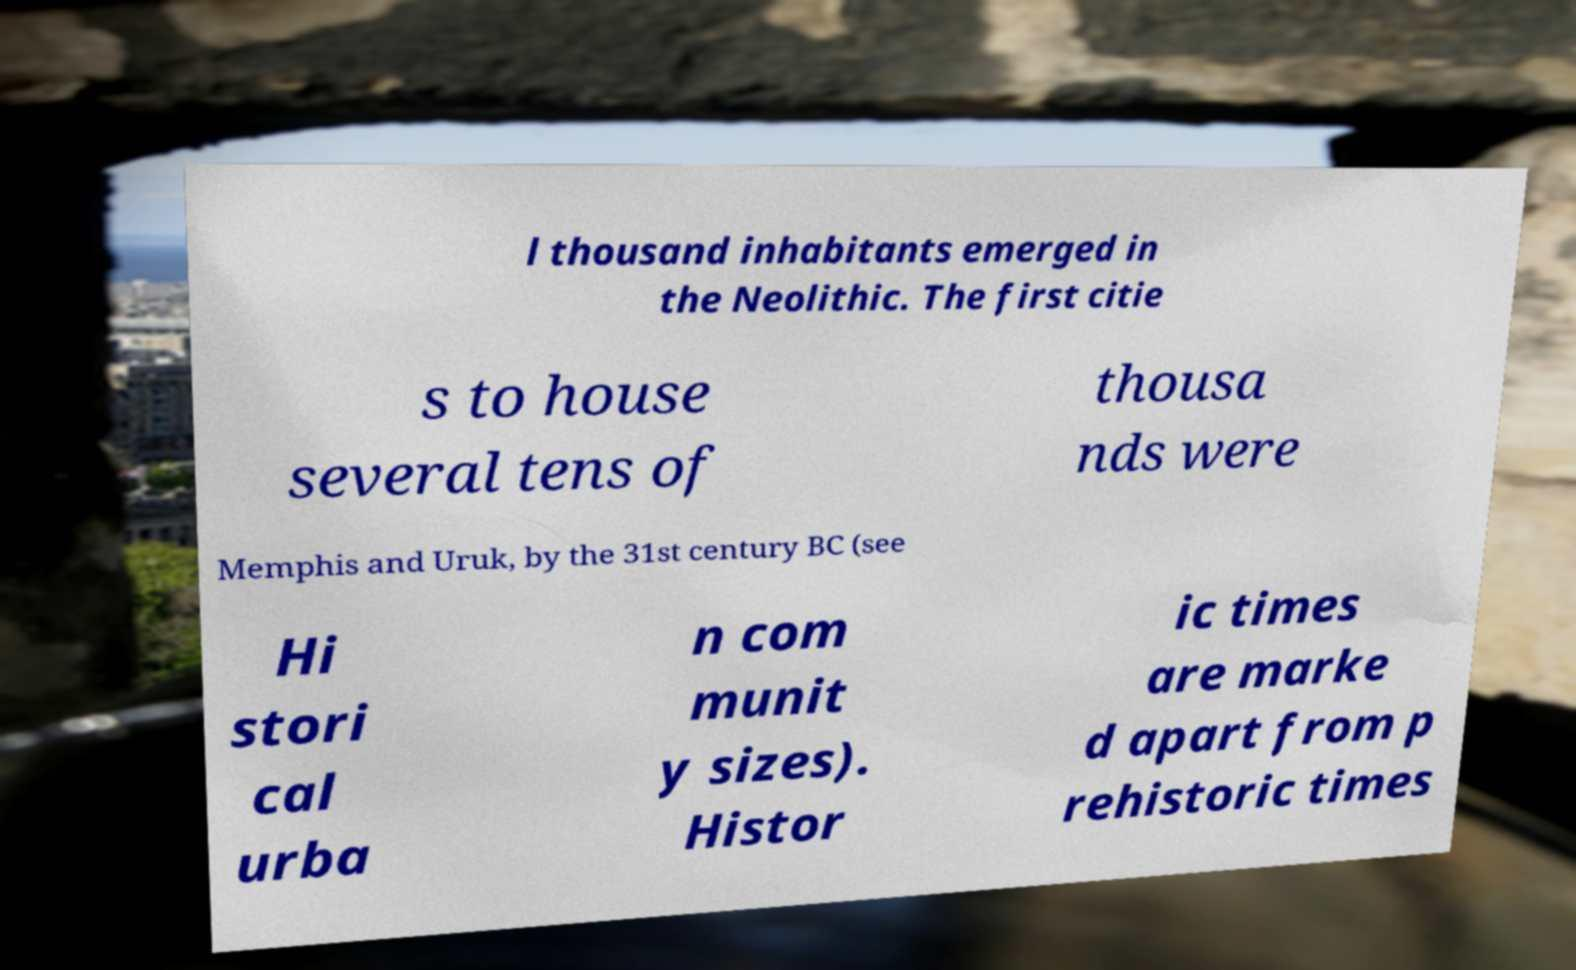For documentation purposes, I need the text within this image transcribed. Could you provide that? l thousand inhabitants emerged in the Neolithic. The first citie s to house several tens of thousa nds were Memphis and Uruk, by the 31st century BC (see Hi stori cal urba n com munit y sizes). Histor ic times are marke d apart from p rehistoric times 